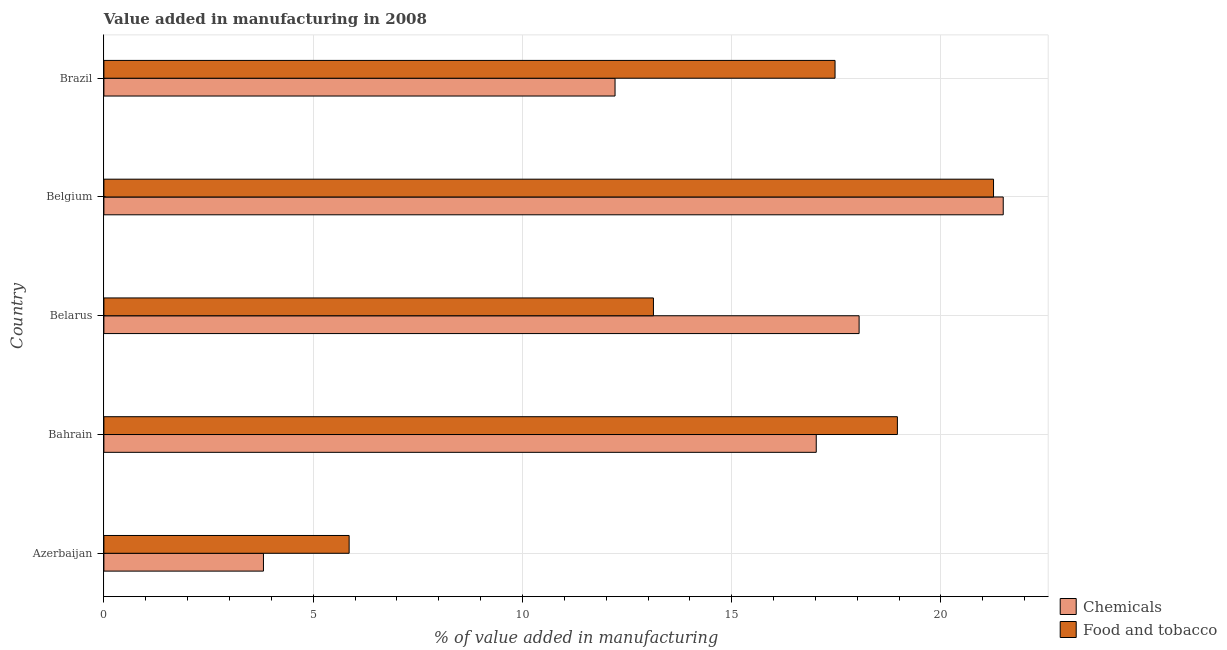How many bars are there on the 2nd tick from the top?
Ensure brevity in your answer.  2. How many bars are there on the 3rd tick from the bottom?
Offer a very short reply. 2. What is the label of the 4th group of bars from the top?
Give a very brief answer. Bahrain. In how many cases, is the number of bars for a given country not equal to the number of legend labels?
Your response must be concise. 0. What is the value added by  manufacturing chemicals in Belgium?
Keep it short and to the point. 21.49. Across all countries, what is the maximum value added by  manufacturing chemicals?
Ensure brevity in your answer.  21.49. Across all countries, what is the minimum value added by manufacturing food and tobacco?
Keep it short and to the point. 5.86. In which country was the value added by  manufacturing chemicals maximum?
Ensure brevity in your answer.  Belgium. In which country was the value added by  manufacturing chemicals minimum?
Provide a succinct answer. Azerbaijan. What is the total value added by manufacturing food and tobacco in the graph?
Provide a short and direct response. 76.67. What is the difference between the value added by manufacturing food and tobacco in Bahrain and that in Belgium?
Your answer should be very brief. -2.3. What is the difference between the value added by manufacturing food and tobacco in Azerbaijan and the value added by  manufacturing chemicals in Belgium?
Offer a very short reply. -15.63. What is the average value added by  manufacturing chemicals per country?
Offer a terse response. 14.52. What is the difference between the value added by manufacturing food and tobacco and value added by  manufacturing chemicals in Bahrain?
Offer a terse response. 1.94. In how many countries, is the value added by  manufacturing chemicals greater than 11 %?
Provide a succinct answer. 4. What is the ratio of the value added by manufacturing food and tobacco in Azerbaijan to that in Brazil?
Give a very brief answer. 0.34. Is the value added by manufacturing food and tobacco in Belgium less than that in Brazil?
Your response must be concise. No. What is the difference between the highest and the second highest value added by manufacturing food and tobacco?
Give a very brief answer. 2.3. What is the difference between the highest and the lowest value added by  manufacturing chemicals?
Give a very brief answer. 17.67. Is the sum of the value added by manufacturing food and tobacco in Bahrain and Belarus greater than the maximum value added by  manufacturing chemicals across all countries?
Provide a short and direct response. Yes. What does the 2nd bar from the top in Belarus represents?
Your answer should be very brief. Chemicals. What does the 1st bar from the bottom in Belarus represents?
Your answer should be compact. Chemicals. Are the values on the major ticks of X-axis written in scientific E-notation?
Provide a short and direct response. No. Does the graph contain any zero values?
Offer a very short reply. No. Does the graph contain grids?
Offer a terse response. Yes. How many legend labels are there?
Ensure brevity in your answer.  2. How are the legend labels stacked?
Your answer should be compact. Vertical. What is the title of the graph?
Your answer should be very brief. Value added in manufacturing in 2008. Does "Net National savings" appear as one of the legend labels in the graph?
Keep it short and to the point. No. What is the label or title of the X-axis?
Offer a terse response. % of value added in manufacturing. What is the % of value added in manufacturing in Chemicals in Azerbaijan?
Your response must be concise. 3.81. What is the % of value added in manufacturing in Food and tobacco in Azerbaijan?
Your response must be concise. 5.86. What is the % of value added in manufacturing of Chemicals in Bahrain?
Your answer should be very brief. 17.02. What is the % of value added in manufacturing in Food and tobacco in Bahrain?
Your answer should be compact. 18.96. What is the % of value added in manufacturing in Chemicals in Belarus?
Make the answer very short. 18.04. What is the % of value added in manufacturing of Food and tobacco in Belarus?
Give a very brief answer. 13.13. What is the % of value added in manufacturing in Chemicals in Belgium?
Provide a succinct answer. 21.49. What is the % of value added in manufacturing of Food and tobacco in Belgium?
Keep it short and to the point. 21.26. What is the % of value added in manufacturing in Chemicals in Brazil?
Make the answer very short. 12.21. What is the % of value added in manufacturing of Food and tobacco in Brazil?
Make the answer very short. 17.47. Across all countries, what is the maximum % of value added in manufacturing of Chemicals?
Offer a very short reply. 21.49. Across all countries, what is the maximum % of value added in manufacturing of Food and tobacco?
Offer a terse response. 21.26. Across all countries, what is the minimum % of value added in manufacturing of Chemicals?
Your answer should be very brief. 3.81. Across all countries, what is the minimum % of value added in manufacturing in Food and tobacco?
Your answer should be compact. 5.86. What is the total % of value added in manufacturing of Chemicals in the graph?
Your answer should be compact. 72.58. What is the total % of value added in manufacturing of Food and tobacco in the graph?
Offer a terse response. 76.67. What is the difference between the % of value added in manufacturing of Chemicals in Azerbaijan and that in Bahrain?
Your response must be concise. -13.21. What is the difference between the % of value added in manufacturing of Food and tobacco in Azerbaijan and that in Bahrain?
Offer a terse response. -13.1. What is the difference between the % of value added in manufacturing of Chemicals in Azerbaijan and that in Belarus?
Provide a short and direct response. -14.23. What is the difference between the % of value added in manufacturing of Food and tobacco in Azerbaijan and that in Belarus?
Your response must be concise. -7.27. What is the difference between the % of value added in manufacturing of Chemicals in Azerbaijan and that in Belgium?
Give a very brief answer. -17.67. What is the difference between the % of value added in manufacturing of Food and tobacco in Azerbaijan and that in Belgium?
Provide a succinct answer. -15.4. What is the difference between the % of value added in manufacturing in Chemicals in Azerbaijan and that in Brazil?
Ensure brevity in your answer.  -8.4. What is the difference between the % of value added in manufacturing in Food and tobacco in Azerbaijan and that in Brazil?
Provide a short and direct response. -11.61. What is the difference between the % of value added in manufacturing in Chemicals in Bahrain and that in Belarus?
Your answer should be very brief. -1.02. What is the difference between the % of value added in manufacturing in Food and tobacco in Bahrain and that in Belarus?
Your response must be concise. 5.83. What is the difference between the % of value added in manufacturing in Chemicals in Bahrain and that in Belgium?
Keep it short and to the point. -4.47. What is the difference between the % of value added in manufacturing of Food and tobacco in Bahrain and that in Belgium?
Provide a succinct answer. -2.3. What is the difference between the % of value added in manufacturing of Chemicals in Bahrain and that in Brazil?
Provide a succinct answer. 4.81. What is the difference between the % of value added in manufacturing in Food and tobacco in Bahrain and that in Brazil?
Give a very brief answer. 1.49. What is the difference between the % of value added in manufacturing of Chemicals in Belarus and that in Belgium?
Offer a terse response. -3.44. What is the difference between the % of value added in manufacturing of Food and tobacco in Belarus and that in Belgium?
Ensure brevity in your answer.  -8.13. What is the difference between the % of value added in manufacturing in Chemicals in Belarus and that in Brazil?
Give a very brief answer. 5.83. What is the difference between the % of value added in manufacturing in Food and tobacco in Belarus and that in Brazil?
Make the answer very short. -4.34. What is the difference between the % of value added in manufacturing in Chemicals in Belgium and that in Brazil?
Make the answer very short. 9.27. What is the difference between the % of value added in manufacturing in Food and tobacco in Belgium and that in Brazil?
Your answer should be very brief. 3.79. What is the difference between the % of value added in manufacturing of Chemicals in Azerbaijan and the % of value added in manufacturing of Food and tobacco in Bahrain?
Provide a short and direct response. -15.15. What is the difference between the % of value added in manufacturing of Chemicals in Azerbaijan and the % of value added in manufacturing of Food and tobacco in Belarus?
Make the answer very short. -9.32. What is the difference between the % of value added in manufacturing in Chemicals in Azerbaijan and the % of value added in manufacturing in Food and tobacco in Belgium?
Offer a terse response. -17.44. What is the difference between the % of value added in manufacturing in Chemicals in Azerbaijan and the % of value added in manufacturing in Food and tobacco in Brazil?
Make the answer very short. -13.66. What is the difference between the % of value added in manufacturing of Chemicals in Bahrain and the % of value added in manufacturing of Food and tobacco in Belarus?
Your answer should be compact. 3.89. What is the difference between the % of value added in manufacturing in Chemicals in Bahrain and the % of value added in manufacturing in Food and tobacco in Belgium?
Offer a very short reply. -4.24. What is the difference between the % of value added in manufacturing in Chemicals in Bahrain and the % of value added in manufacturing in Food and tobacco in Brazil?
Provide a succinct answer. -0.45. What is the difference between the % of value added in manufacturing in Chemicals in Belarus and the % of value added in manufacturing in Food and tobacco in Belgium?
Ensure brevity in your answer.  -3.21. What is the difference between the % of value added in manufacturing of Chemicals in Belarus and the % of value added in manufacturing of Food and tobacco in Brazil?
Make the answer very short. 0.57. What is the difference between the % of value added in manufacturing of Chemicals in Belgium and the % of value added in manufacturing of Food and tobacco in Brazil?
Keep it short and to the point. 4.02. What is the average % of value added in manufacturing of Chemicals per country?
Your answer should be very brief. 14.52. What is the average % of value added in manufacturing of Food and tobacco per country?
Provide a succinct answer. 15.33. What is the difference between the % of value added in manufacturing of Chemicals and % of value added in manufacturing of Food and tobacco in Azerbaijan?
Make the answer very short. -2.05. What is the difference between the % of value added in manufacturing of Chemicals and % of value added in manufacturing of Food and tobacco in Bahrain?
Your answer should be compact. -1.94. What is the difference between the % of value added in manufacturing in Chemicals and % of value added in manufacturing in Food and tobacco in Belarus?
Offer a terse response. 4.91. What is the difference between the % of value added in manufacturing in Chemicals and % of value added in manufacturing in Food and tobacco in Belgium?
Make the answer very short. 0.23. What is the difference between the % of value added in manufacturing of Chemicals and % of value added in manufacturing of Food and tobacco in Brazil?
Your answer should be compact. -5.26. What is the ratio of the % of value added in manufacturing of Chemicals in Azerbaijan to that in Bahrain?
Ensure brevity in your answer.  0.22. What is the ratio of the % of value added in manufacturing in Food and tobacco in Azerbaijan to that in Bahrain?
Offer a very short reply. 0.31. What is the ratio of the % of value added in manufacturing of Chemicals in Azerbaijan to that in Belarus?
Provide a succinct answer. 0.21. What is the ratio of the % of value added in manufacturing in Food and tobacco in Azerbaijan to that in Belarus?
Ensure brevity in your answer.  0.45. What is the ratio of the % of value added in manufacturing of Chemicals in Azerbaijan to that in Belgium?
Your answer should be very brief. 0.18. What is the ratio of the % of value added in manufacturing of Food and tobacco in Azerbaijan to that in Belgium?
Offer a terse response. 0.28. What is the ratio of the % of value added in manufacturing of Chemicals in Azerbaijan to that in Brazil?
Offer a terse response. 0.31. What is the ratio of the % of value added in manufacturing of Food and tobacco in Azerbaijan to that in Brazil?
Provide a short and direct response. 0.34. What is the ratio of the % of value added in manufacturing in Chemicals in Bahrain to that in Belarus?
Make the answer very short. 0.94. What is the ratio of the % of value added in manufacturing of Food and tobacco in Bahrain to that in Belarus?
Provide a succinct answer. 1.44. What is the ratio of the % of value added in manufacturing of Chemicals in Bahrain to that in Belgium?
Your answer should be very brief. 0.79. What is the ratio of the % of value added in manufacturing in Food and tobacco in Bahrain to that in Belgium?
Your answer should be very brief. 0.89. What is the ratio of the % of value added in manufacturing of Chemicals in Bahrain to that in Brazil?
Make the answer very short. 1.39. What is the ratio of the % of value added in manufacturing of Food and tobacco in Bahrain to that in Brazil?
Provide a short and direct response. 1.09. What is the ratio of the % of value added in manufacturing in Chemicals in Belarus to that in Belgium?
Offer a terse response. 0.84. What is the ratio of the % of value added in manufacturing in Food and tobacco in Belarus to that in Belgium?
Your answer should be very brief. 0.62. What is the ratio of the % of value added in manufacturing of Chemicals in Belarus to that in Brazil?
Your response must be concise. 1.48. What is the ratio of the % of value added in manufacturing of Food and tobacco in Belarus to that in Brazil?
Make the answer very short. 0.75. What is the ratio of the % of value added in manufacturing in Chemicals in Belgium to that in Brazil?
Make the answer very short. 1.76. What is the ratio of the % of value added in manufacturing in Food and tobacco in Belgium to that in Brazil?
Your answer should be very brief. 1.22. What is the difference between the highest and the second highest % of value added in manufacturing of Chemicals?
Offer a terse response. 3.44. What is the difference between the highest and the second highest % of value added in manufacturing of Food and tobacco?
Provide a succinct answer. 2.3. What is the difference between the highest and the lowest % of value added in manufacturing of Chemicals?
Offer a terse response. 17.67. What is the difference between the highest and the lowest % of value added in manufacturing in Food and tobacco?
Your response must be concise. 15.4. 